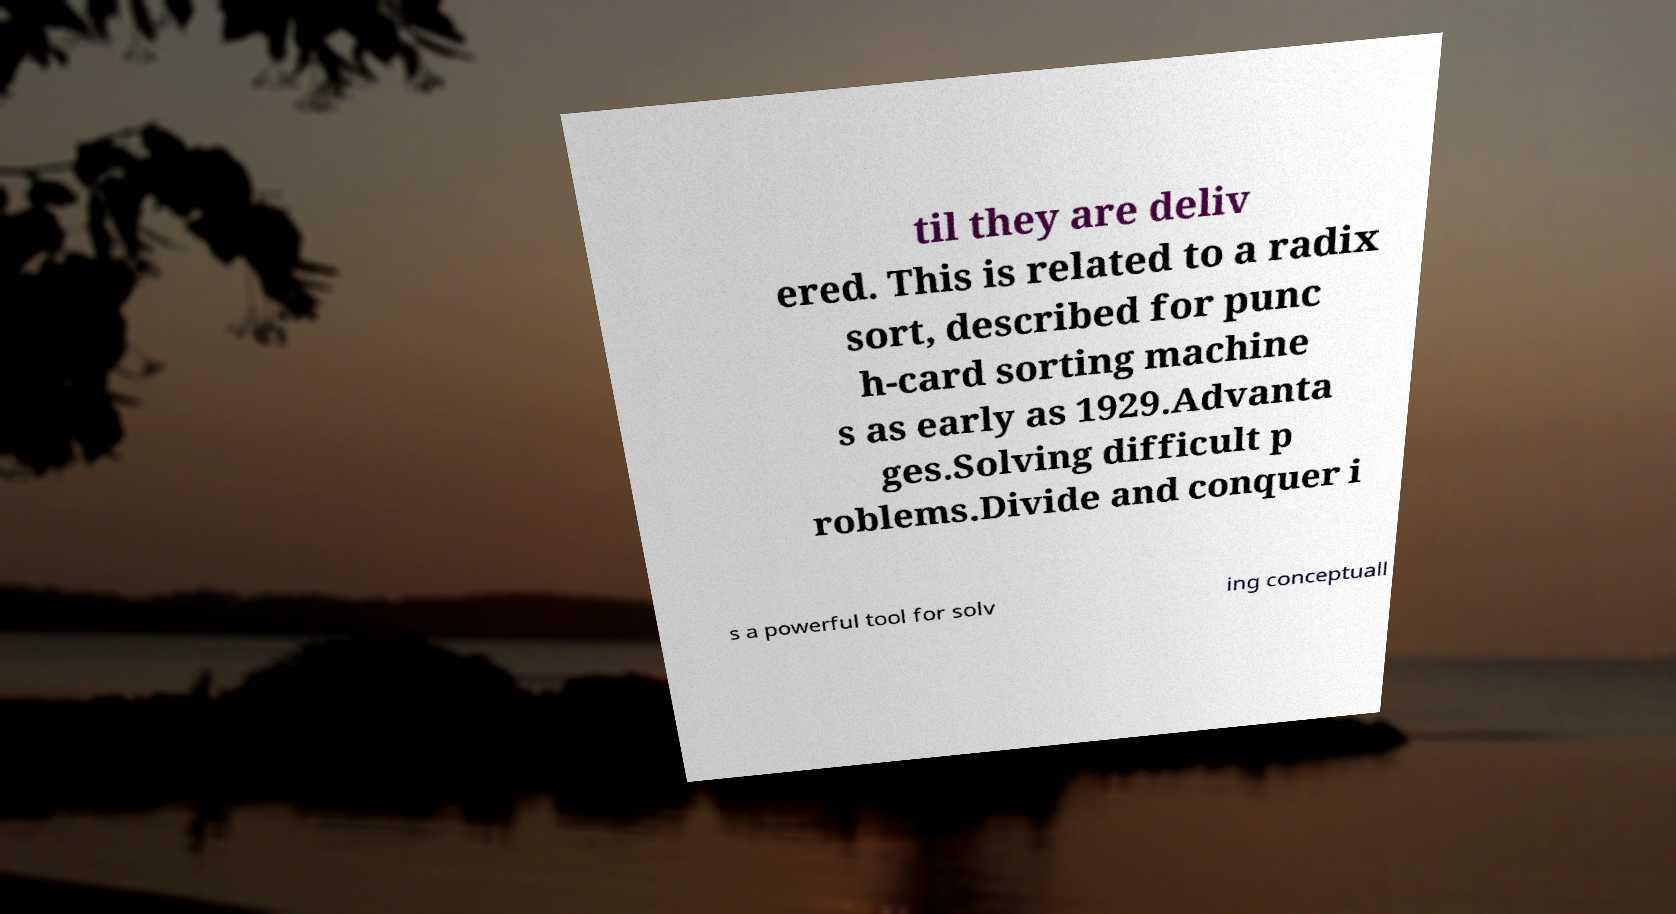Please identify and transcribe the text found in this image. til they are deliv ered. This is related to a radix sort, described for punc h-card sorting machine s as early as 1929.Advanta ges.Solving difficult p roblems.Divide and conquer i s a powerful tool for solv ing conceptuall 